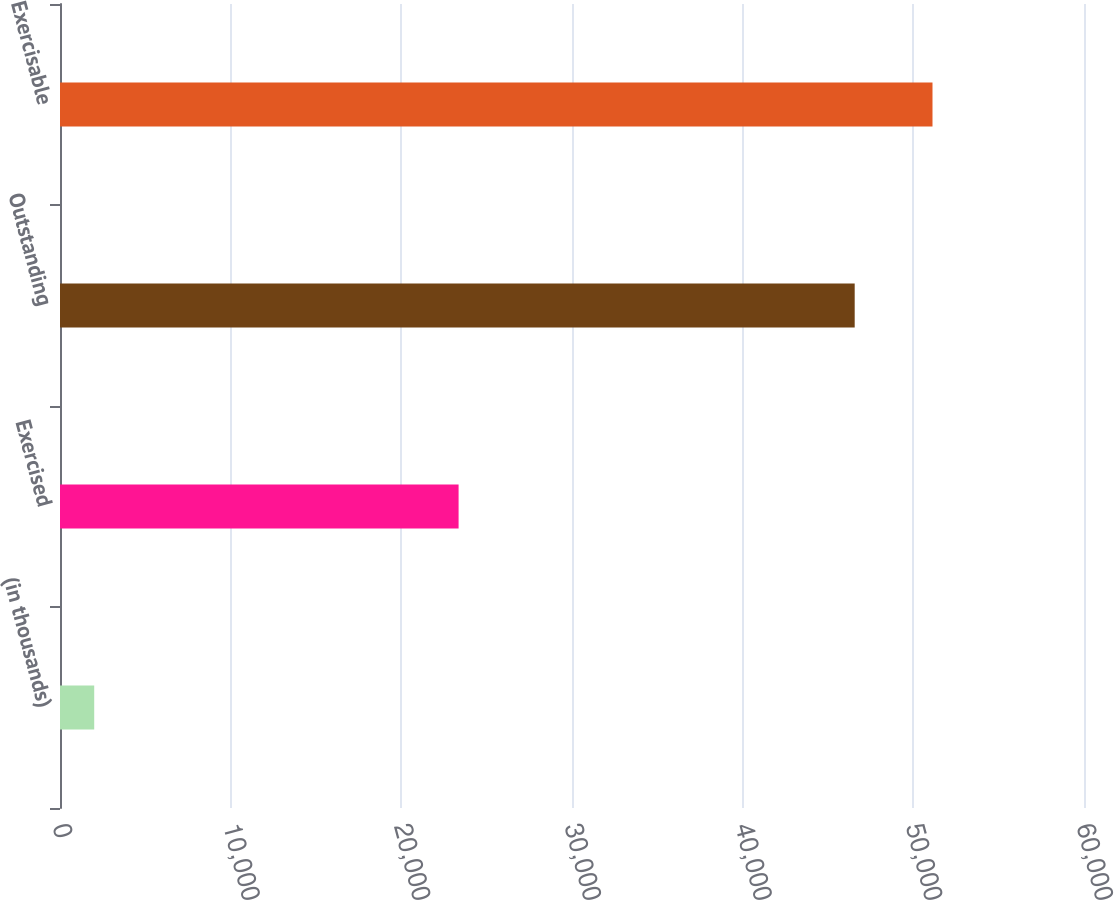Convert chart. <chart><loc_0><loc_0><loc_500><loc_500><bar_chart><fcel>(in thousands)<fcel>Exercised<fcel>Outstanding<fcel>Exercisable<nl><fcel>2005<fcel>23355<fcel>46564<fcel>51122.9<nl></chart> 